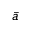<formula> <loc_0><loc_0><loc_500><loc_500>\bar { a }</formula> 